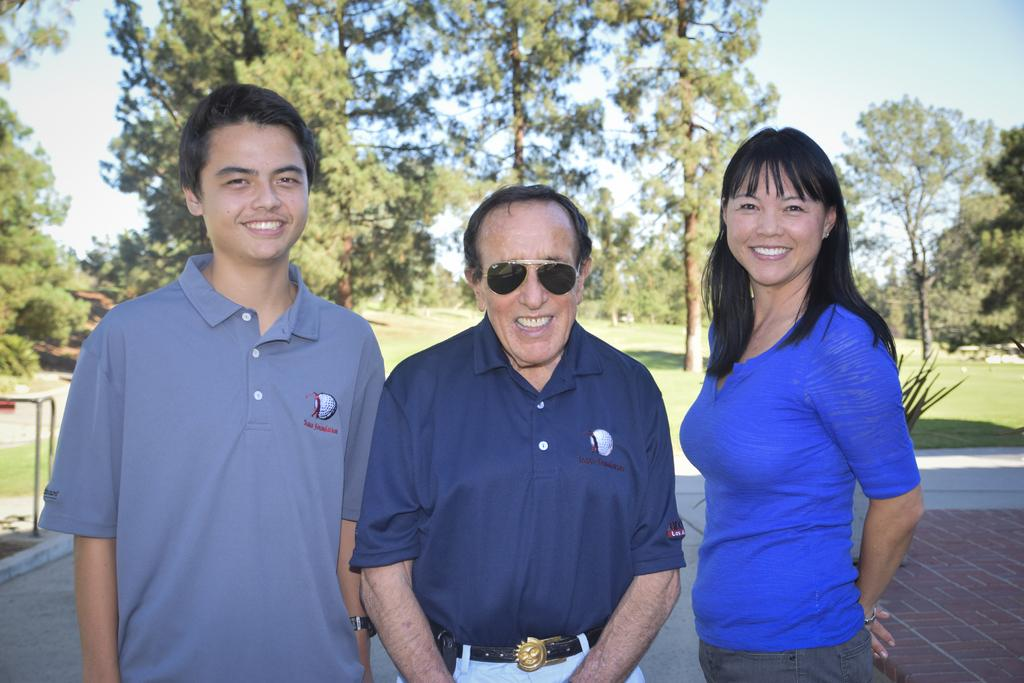How many people are in the image? There are three persons in the image. Can you describe the gender of the persons? Two of the persons are men, and one is a woman. What are the persons doing in the image? The three persons are standing and posing for a photograph. What can be seen in the background of the image? There are trees, grass, and the clear sky visible in the background of the image. What type of pickle is being used as a prop in the image? There is no pickle present in the image. What design elements can be seen on the woman's clothing in the image? The provided facts do not mention any design elements on the woman's clothing. Is there any lettuce visible in the image? There is no lettuce present in the image. 